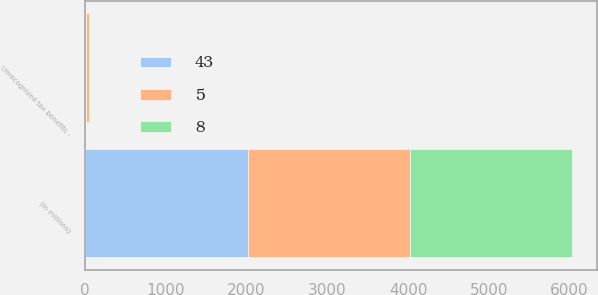Convert chart. <chart><loc_0><loc_0><loc_500><loc_500><stacked_bar_chart><ecel><fcel>(in millions)<fcel>Unrecognized tax benefits -<nl><fcel>43<fcel>2012<fcel>8<nl><fcel>8<fcel>2011<fcel>5<nl><fcel>5<fcel>2010<fcel>43<nl></chart> 